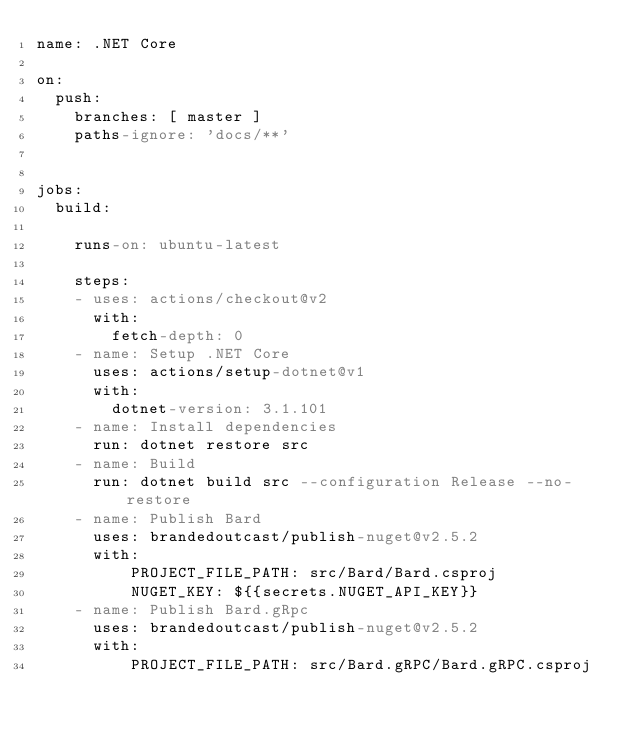<code> <loc_0><loc_0><loc_500><loc_500><_YAML_>name: .NET Core

on:
  push:
    branches: [ master ]  
    paths-ignore: 'docs/**'


jobs:
  build:

    runs-on: ubuntu-latest

    steps:
    - uses: actions/checkout@v2
      with:
        fetch-depth: 0     
    - name: Setup .NET Core
      uses: actions/setup-dotnet@v1
      with:
        dotnet-version: 3.1.101
    - name: Install dependencies
      run: dotnet restore src
    - name: Build
      run: dotnet build src --configuration Release --no-restore  
    - name: Publish Bard
      uses: brandedoutcast/publish-nuget@v2.5.2
      with:
          PROJECT_FILE_PATH: src/Bard/Bard.csproj
          NUGET_KEY: ${{secrets.NUGET_API_KEY}}
    - name: Publish Bard.gRpc
      uses: brandedoutcast/publish-nuget@v2.5.2
      with:
          PROJECT_FILE_PATH: src/Bard.gRPC/Bard.gRPC.csproj</code> 